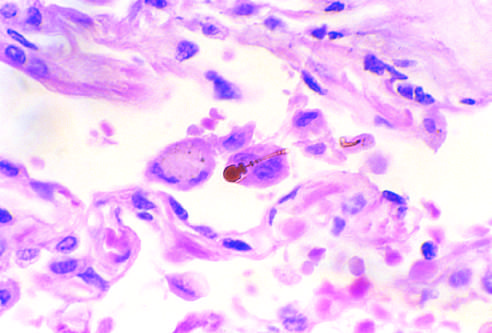does the high-power detail of an asbestos body reveal the typical beading and knobbed ends?
Answer the question using a single word or phrase. Yes 